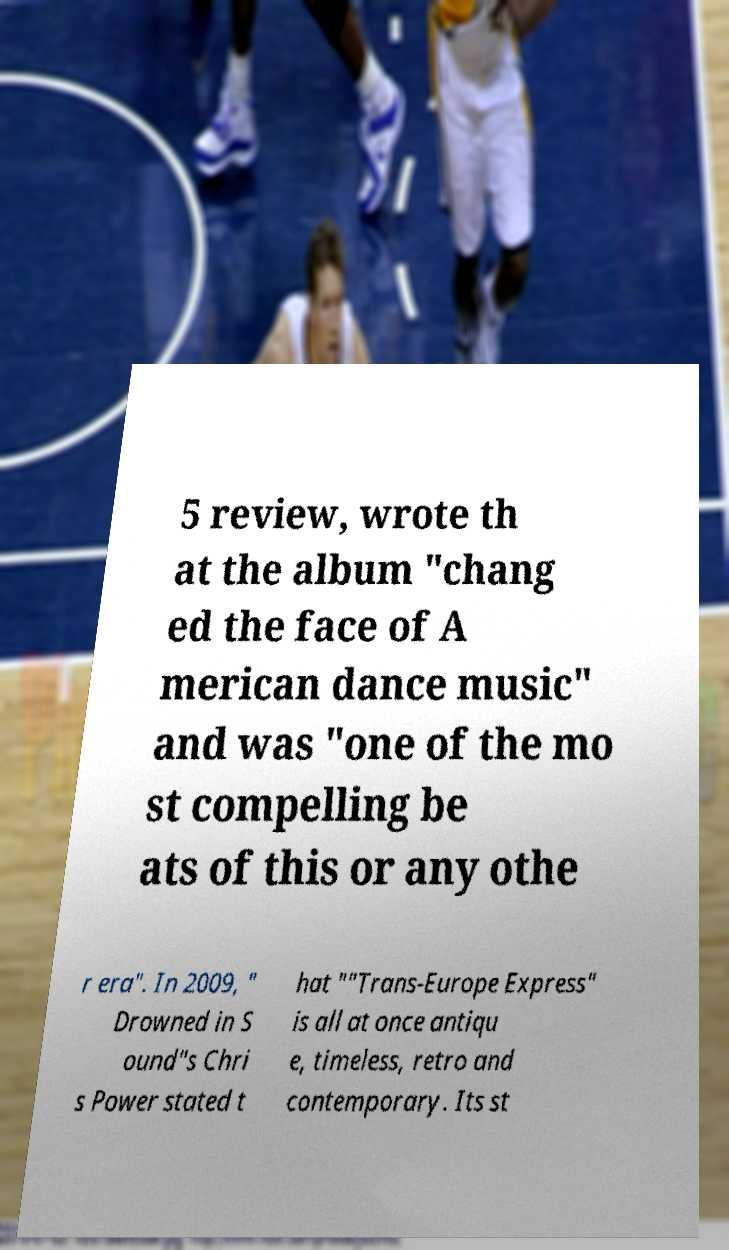Please read and relay the text visible in this image. What does it say? 5 review, wrote th at the album "chang ed the face of A merican dance music" and was "one of the mo st compelling be ats of this or any othe r era". In 2009, " Drowned in S ound"s Chri s Power stated t hat ""Trans-Europe Express" is all at once antiqu e, timeless, retro and contemporary. Its st 